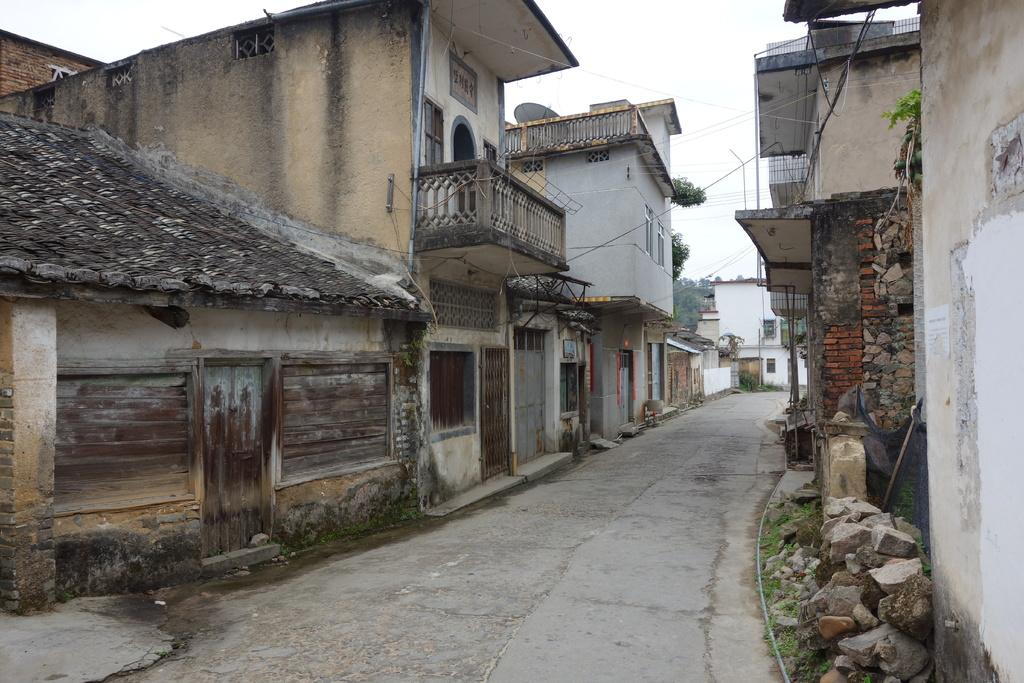What can be seen in the image that people might walk on? There is a path in the image that people might walk on. What type of material is present in the image? There are stones in the image. What are some features of the buildings in the image? The buildings in the image have windows and doors. What else is present in the image besides the path, stones, and buildings? There are objects in the image. What can be seen in the background of the image? There are trees and the sky visible in the background of the image. What type of celery can be seen growing in the image? There is no celery present in the image. What ideas are being discussed by the people in the image? There are no people or discussions visible in the image. 